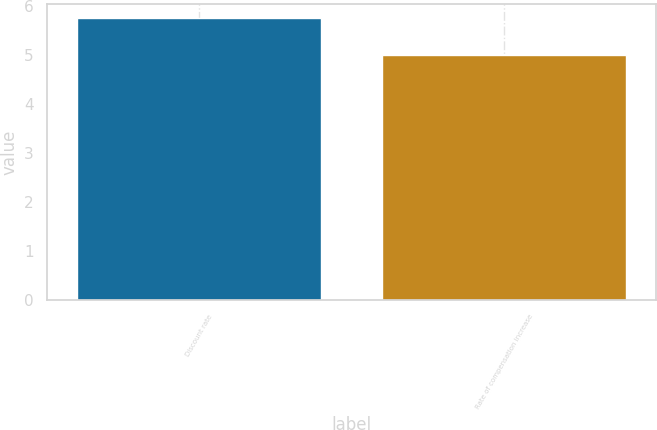Convert chart to OTSL. <chart><loc_0><loc_0><loc_500><loc_500><bar_chart><fcel>Discount rate<fcel>Rate of compensation increase<nl><fcel>5.75<fcel>5<nl></chart> 